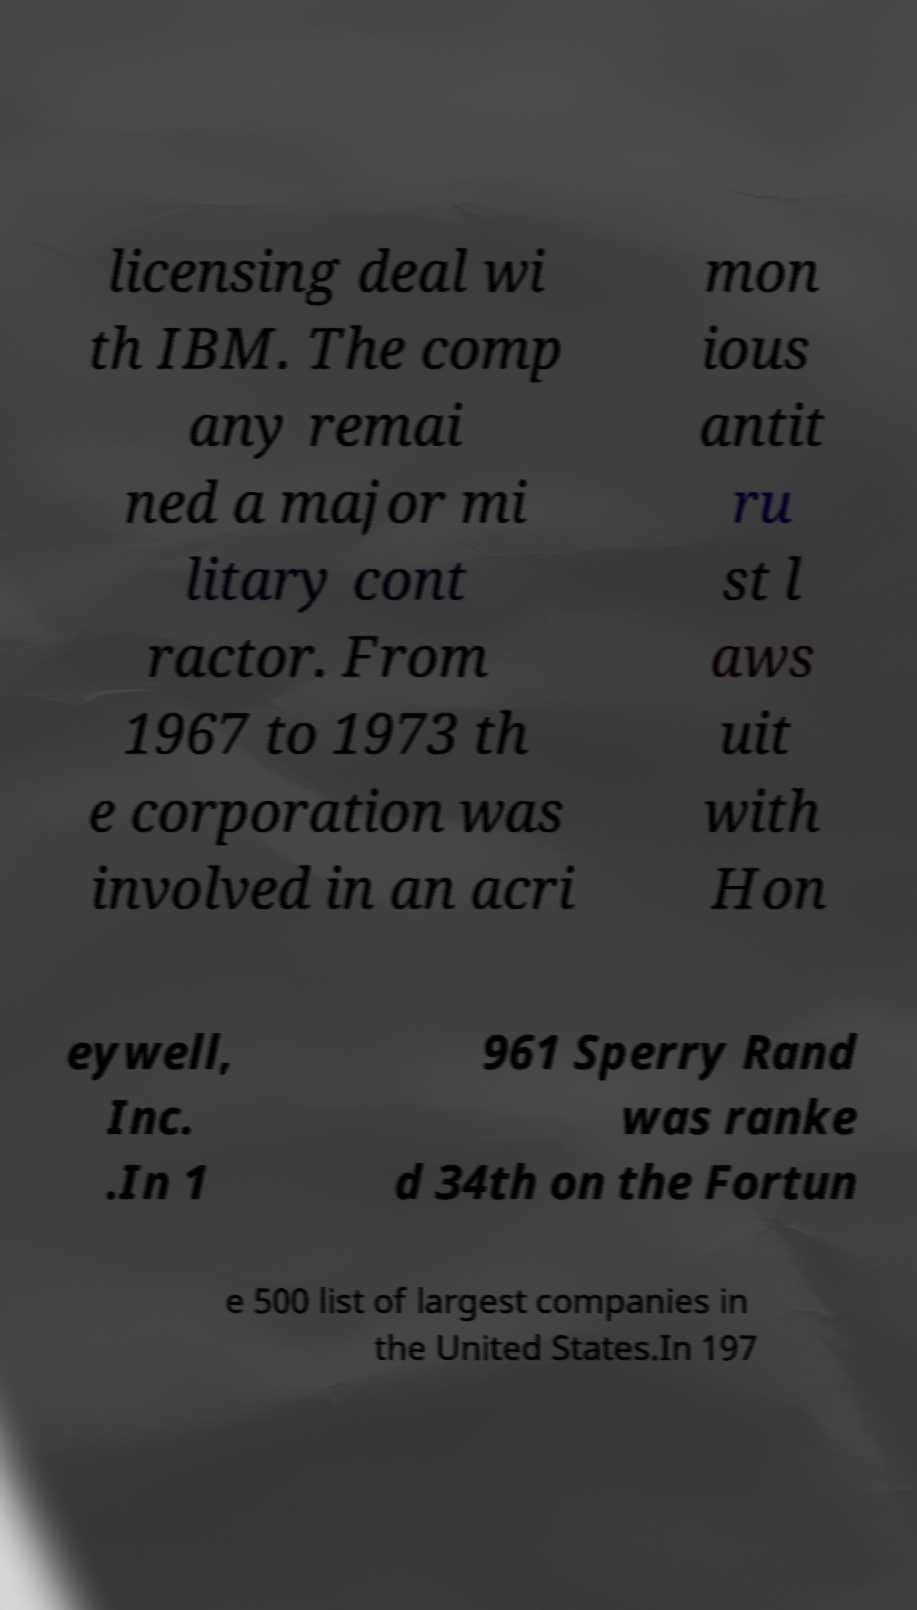I need the written content from this picture converted into text. Can you do that? licensing deal wi th IBM. The comp any remai ned a major mi litary cont ractor. From 1967 to 1973 th e corporation was involved in an acri mon ious antit ru st l aws uit with Hon eywell, Inc. .In 1 961 Sperry Rand was ranke d 34th on the Fortun e 500 list of largest companies in the United States.In 197 